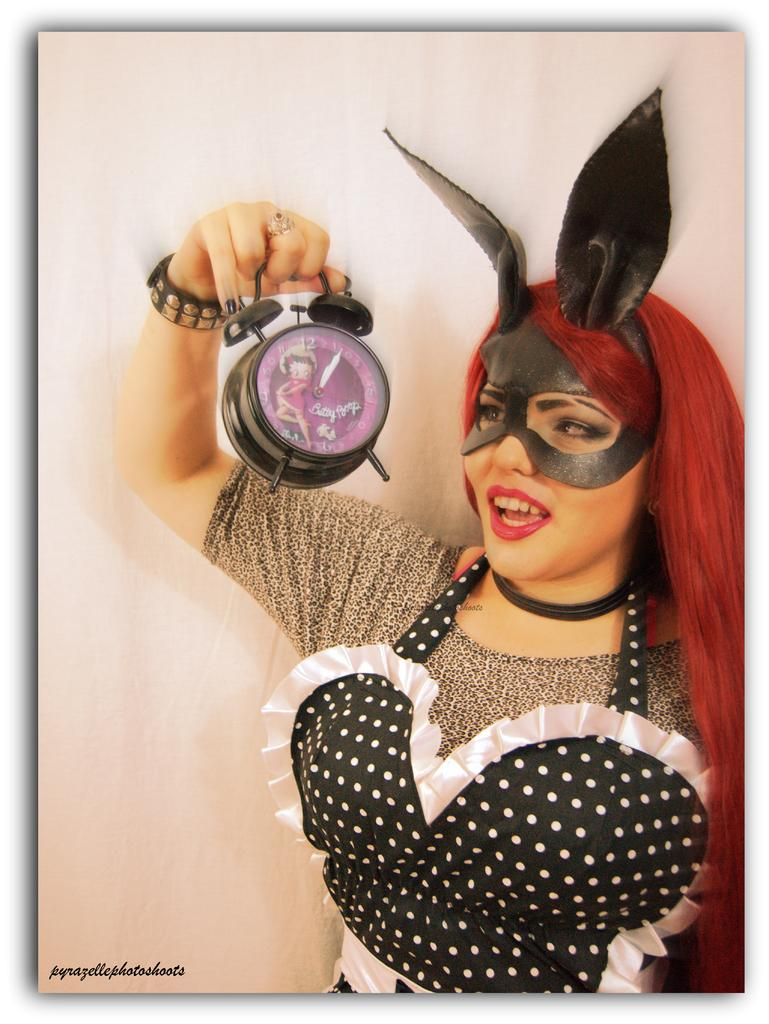What is the main subject of the image? The main subject of the image is a woman. Can you describe what the woman is wearing? The woman is wearing a mask. What object is the woman holding in the image? The woman is holding an alarm clock. Can you tell me how many times the woman jumps in the image? There is no indication in the image that the woman is jumping, so it cannot be determined from the picture. What type of material is the maid's uniform made of in the image? There is no maid present in the image, and therefore no such uniform can be observed. 